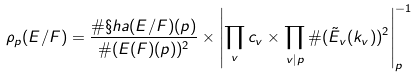Convert formula to latex. <formula><loc_0><loc_0><loc_500><loc_500>\rho _ { p } ( E / F ) = \frac { \# \S h a ( E / F ) ( p ) } { \# ( E ( F ) ( p ) ) ^ { 2 } } \times \left | \prod _ { v } c _ { v } \times \prod _ { v | p } \# ( \tilde { E } _ { v } ( k _ { v } ) ) ^ { 2 } \right | _ { p } ^ { - 1 }</formula> 